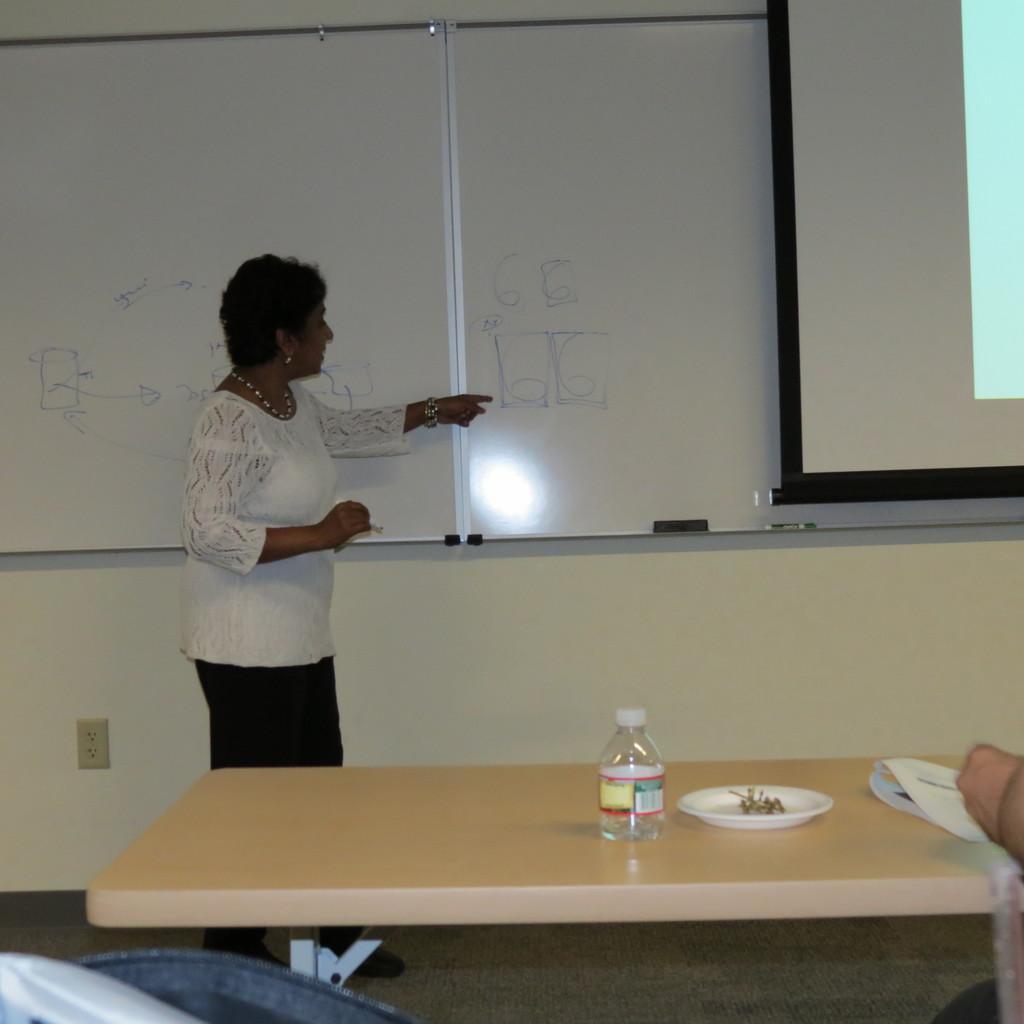How would you summarize this image in a sentence or two? The woman in white shirt and black pant is holding a marker in her hand and she is explaining something on the white board. Beside that, we see a projector screen. In front of her, we see a table on which plate, paper and water bottle are placed. Behind her, we see a white wall. This picture is clicked inside the room. 